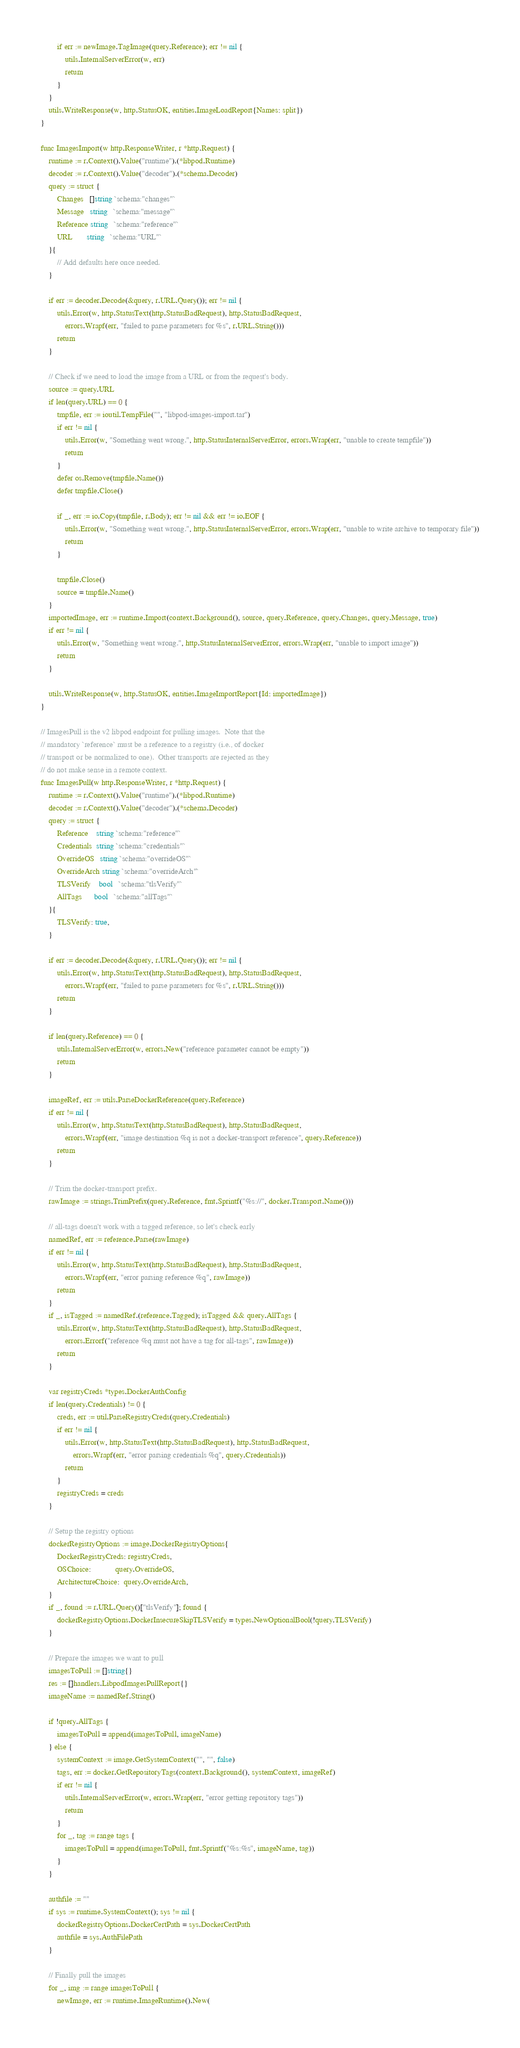<code> <loc_0><loc_0><loc_500><loc_500><_Go_>		if err := newImage.TagImage(query.Reference); err != nil {
			utils.InternalServerError(w, err)
			return
		}
	}
	utils.WriteResponse(w, http.StatusOK, entities.ImageLoadReport{Names: split})
}

func ImagesImport(w http.ResponseWriter, r *http.Request) {
	runtime := r.Context().Value("runtime").(*libpod.Runtime)
	decoder := r.Context().Value("decoder").(*schema.Decoder)
	query := struct {
		Changes   []string `schema:"changes"`
		Message   string   `schema:"message"`
		Reference string   `schema:"reference"`
		URL       string   `schema:"URL"`
	}{
		// Add defaults here once needed.
	}

	if err := decoder.Decode(&query, r.URL.Query()); err != nil {
		utils.Error(w, http.StatusText(http.StatusBadRequest), http.StatusBadRequest,
			errors.Wrapf(err, "failed to parse parameters for %s", r.URL.String()))
		return
	}

	// Check if we need to load the image from a URL or from the request's body.
	source := query.URL
	if len(query.URL) == 0 {
		tmpfile, err := ioutil.TempFile("", "libpod-images-import.tar")
		if err != nil {
			utils.Error(w, "Something went wrong.", http.StatusInternalServerError, errors.Wrap(err, "unable to create tempfile"))
			return
		}
		defer os.Remove(tmpfile.Name())
		defer tmpfile.Close()

		if _, err := io.Copy(tmpfile, r.Body); err != nil && err != io.EOF {
			utils.Error(w, "Something went wrong.", http.StatusInternalServerError, errors.Wrap(err, "unable to write archive to temporary file"))
			return
		}

		tmpfile.Close()
		source = tmpfile.Name()
	}
	importedImage, err := runtime.Import(context.Background(), source, query.Reference, query.Changes, query.Message, true)
	if err != nil {
		utils.Error(w, "Something went wrong.", http.StatusInternalServerError, errors.Wrap(err, "unable to import image"))
		return
	}

	utils.WriteResponse(w, http.StatusOK, entities.ImageImportReport{Id: importedImage})
}

// ImagesPull is the v2 libpod endpoint for pulling images.  Note that the
// mandatory `reference` must be a reference to a registry (i.e., of docker
// transport or be normalized to one).  Other transports are rejected as they
// do not make sense in a remote context.
func ImagesPull(w http.ResponseWriter, r *http.Request) {
	runtime := r.Context().Value("runtime").(*libpod.Runtime)
	decoder := r.Context().Value("decoder").(*schema.Decoder)
	query := struct {
		Reference    string `schema:"reference"`
		Credentials  string `schema:"credentials"`
		OverrideOS   string `schema:"overrideOS"`
		OverrideArch string `schema:"overrideArch"`
		TLSVerify    bool   `schema:"tlsVerify"`
		AllTags      bool   `schema:"allTags"`
	}{
		TLSVerify: true,
	}

	if err := decoder.Decode(&query, r.URL.Query()); err != nil {
		utils.Error(w, http.StatusText(http.StatusBadRequest), http.StatusBadRequest,
			errors.Wrapf(err, "failed to parse parameters for %s", r.URL.String()))
		return
	}

	if len(query.Reference) == 0 {
		utils.InternalServerError(w, errors.New("reference parameter cannot be empty"))
		return
	}

	imageRef, err := utils.ParseDockerReference(query.Reference)
	if err != nil {
		utils.Error(w, http.StatusText(http.StatusBadRequest), http.StatusBadRequest,
			errors.Wrapf(err, "image destination %q is not a docker-transport reference", query.Reference))
		return
	}

	// Trim the docker-transport prefix.
	rawImage := strings.TrimPrefix(query.Reference, fmt.Sprintf("%s://", docker.Transport.Name()))

	// all-tags doesn't work with a tagged reference, so let's check early
	namedRef, err := reference.Parse(rawImage)
	if err != nil {
		utils.Error(w, http.StatusText(http.StatusBadRequest), http.StatusBadRequest,
			errors.Wrapf(err, "error parsing reference %q", rawImage))
		return
	}
	if _, isTagged := namedRef.(reference.Tagged); isTagged && query.AllTags {
		utils.Error(w, http.StatusText(http.StatusBadRequest), http.StatusBadRequest,
			errors.Errorf("reference %q must not have a tag for all-tags", rawImage))
		return
	}

	var registryCreds *types.DockerAuthConfig
	if len(query.Credentials) != 0 {
		creds, err := util.ParseRegistryCreds(query.Credentials)
		if err != nil {
			utils.Error(w, http.StatusText(http.StatusBadRequest), http.StatusBadRequest,
				errors.Wrapf(err, "error parsing credentials %q", query.Credentials))
			return
		}
		registryCreds = creds
	}

	// Setup the registry options
	dockerRegistryOptions := image.DockerRegistryOptions{
		DockerRegistryCreds: registryCreds,
		OSChoice:            query.OverrideOS,
		ArchitectureChoice:  query.OverrideArch,
	}
	if _, found := r.URL.Query()["tlsVerify"]; found {
		dockerRegistryOptions.DockerInsecureSkipTLSVerify = types.NewOptionalBool(!query.TLSVerify)
	}

	// Prepare the images we want to pull
	imagesToPull := []string{}
	res := []handlers.LibpodImagesPullReport{}
	imageName := namedRef.String()

	if !query.AllTags {
		imagesToPull = append(imagesToPull, imageName)
	} else {
		systemContext := image.GetSystemContext("", "", false)
		tags, err := docker.GetRepositoryTags(context.Background(), systemContext, imageRef)
		if err != nil {
			utils.InternalServerError(w, errors.Wrap(err, "error getting repository tags"))
			return
		}
		for _, tag := range tags {
			imagesToPull = append(imagesToPull, fmt.Sprintf("%s:%s", imageName, tag))
		}
	}

	authfile := ""
	if sys := runtime.SystemContext(); sys != nil {
		dockerRegistryOptions.DockerCertPath = sys.DockerCertPath
		authfile = sys.AuthFilePath
	}

	// Finally pull the images
	for _, img := range imagesToPull {
		newImage, err := runtime.ImageRuntime().New(</code> 